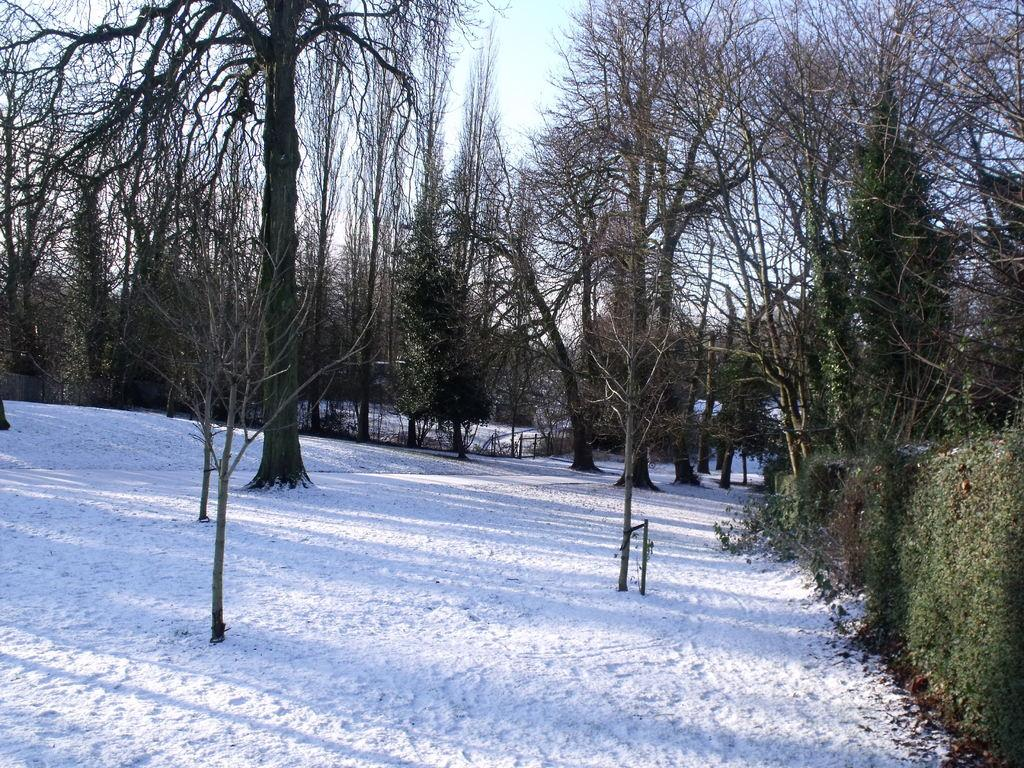What is the weather condition in the image? There is snow in the image, indicating a cold and wintry condition. What type of natural elements can be seen in the image? There are trees in the image. What are the creepers in the image doing? The creeps in the image are likely growing on the trees or other surfaces. What is the condition of the sky in the image? The sky is clear in the image. How many books are visible in the image? There are no books present in the image. What type of wheel can be seen in the image? There is no wheel present in the image. 